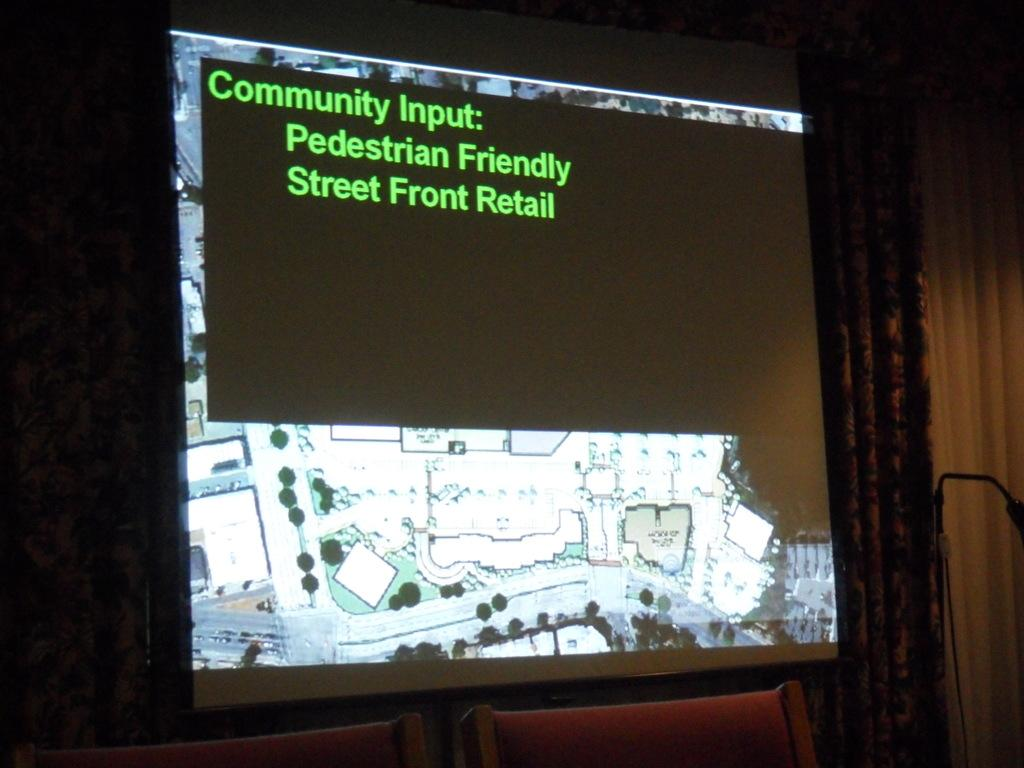What is the main subject of the image? The main subject of the image is a display on a board. Are there any objects or furniture near the board? Yes, there are two chairs in front of the board. What type of guitar is being played by the bone in the image? There is no guitar or bone present in the image; it only features a display on a board and two chairs. 